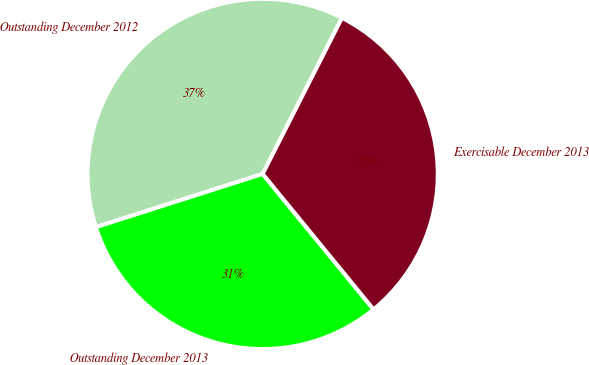<chart> <loc_0><loc_0><loc_500><loc_500><pie_chart><fcel>Outstanding December 2012<fcel>Outstanding December 2013<fcel>Exercisable December 2013<nl><fcel>37.4%<fcel>31.0%<fcel>31.6%<nl></chart> 